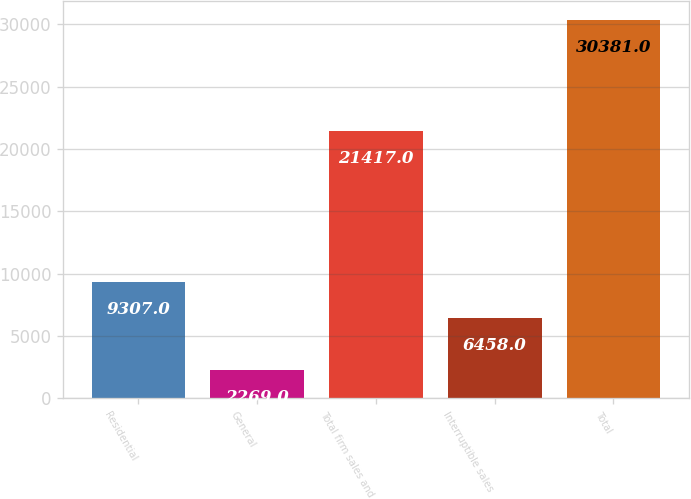Convert chart to OTSL. <chart><loc_0><loc_0><loc_500><loc_500><bar_chart><fcel>Residential<fcel>General<fcel>Total firm sales and<fcel>Interruptible sales<fcel>Total<nl><fcel>9307<fcel>2269<fcel>21417<fcel>6458<fcel>30381<nl></chart> 